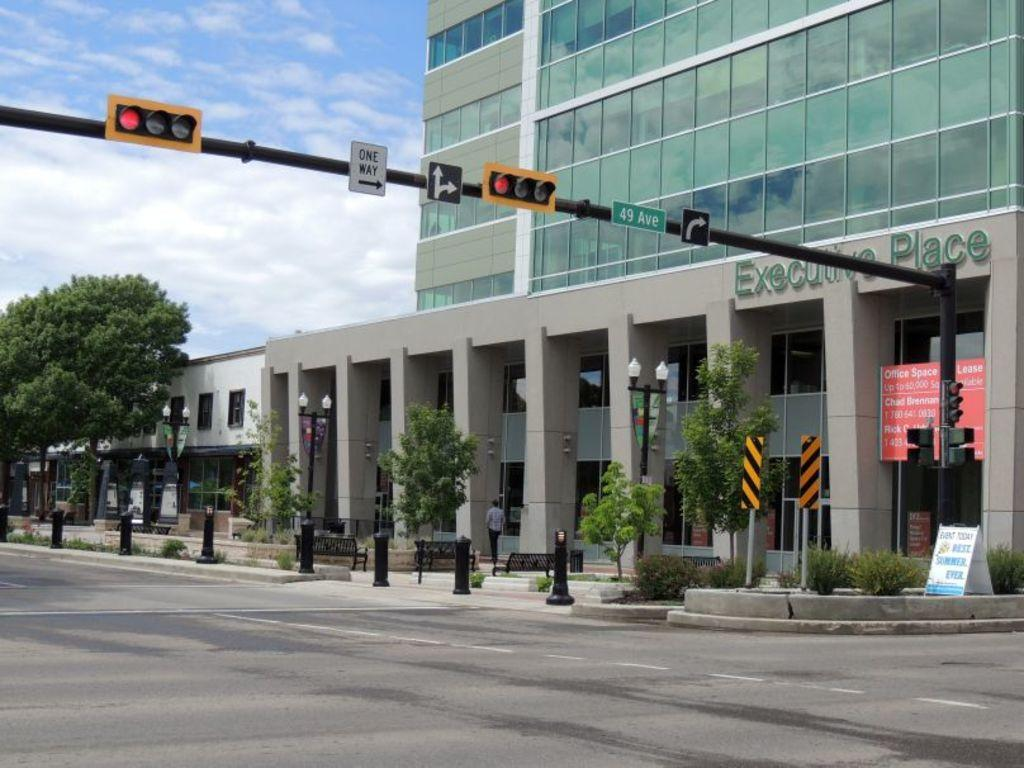<image>
Relay a brief, clear account of the picture shown. The front side of a large building with the words executive place over the entranceway. 